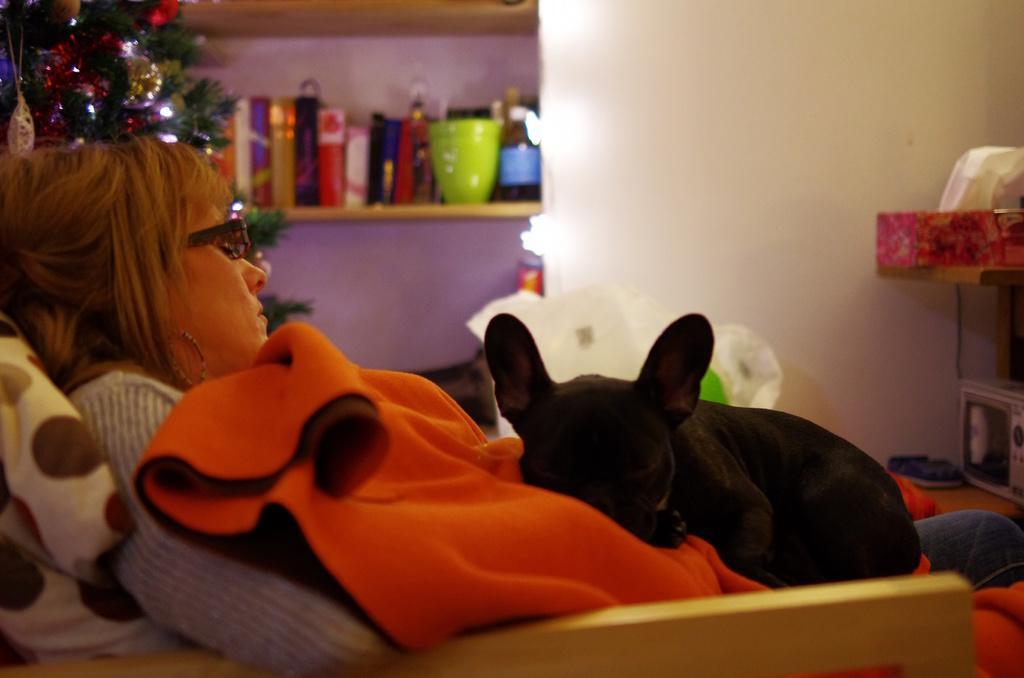Can you describe this image briefly? This is the picture of a room. In this picture there is a woman sitting and there is a dog sitting on the woman. At the back there are books and there is a cup, bottle in the cupboard and there is a Christmas tree. On the right side of the image there is an object on the table and there is a device at the bottom. 